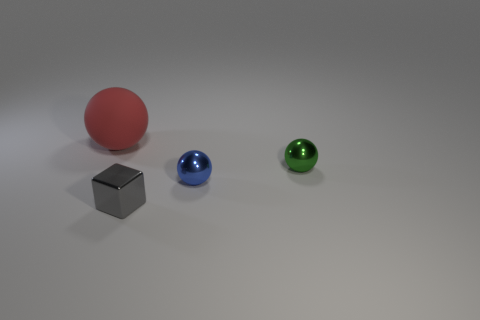Is there any other thing that has the same material as the red sphere?
Your response must be concise. No. How many small red objects are there?
Your answer should be very brief. 0. Is the shape of the red object the same as the metallic object behind the tiny blue thing?
Keep it short and to the point. Yes. How many things are tiny purple metal cubes or small blue objects?
Ensure brevity in your answer.  1. There is a metal thing that is behind the shiny sphere in front of the green shiny object; what is its shape?
Offer a very short reply. Sphere. Does the thing on the left side of the tiny metallic block have the same shape as the tiny blue object?
Your response must be concise. Yes. There is a green object that is the same material as the tiny blue object; what is its size?
Offer a very short reply. Small. How many things are either tiny metallic balls left of the green shiny sphere or tiny balls that are in front of the green metal sphere?
Your answer should be very brief. 1. Are there an equal number of shiny objects that are on the left side of the big matte ball and tiny objects that are on the left side of the small green ball?
Offer a terse response. No. The thing that is left of the cube is what color?
Give a very brief answer. Red. 